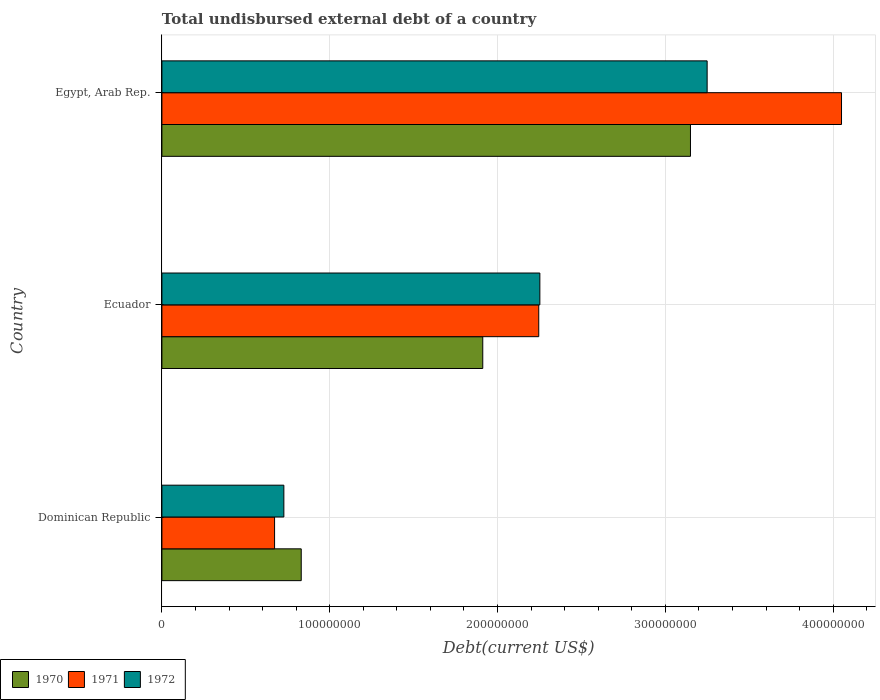How many groups of bars are there?
Make the answer very short. 3. How many bars are there on the 3rd tick from the top?
Keep it short and to the point. 3. What is the label of the 2nd group of bars from the top?
Ensure brevity in your answer.  Ecuador. What is the total undisbursed external debt in 1972 in Egypt, Arab Rep.?
Your answer should be compact. 3.25e+08. Across all countries, what is the maximum total undisbursed external debt in 1971?
Ensure brevity in your answer.  4.05e+08. Across all countries, what is the minimum total undisbursed external debt in 1971?
Make the answer very short. 6.71e+07. In which country was the total undisbursed external debt in 1971 maximum?
Give a very brief answer. Egypt, Arab Rep. In which country was the total undisbursed external debt in 1971 minimum?
Provide a short and direct response. Dominican Republic. What is the total total undisbursed external debt in 1971 in the graph?
Keep it short and to the point. 6.97e+08. What is the difference between the total undisbursed external debt in 1972 in Ecuador and that in Egypt, Arab Rep.?
Your answer should be very brief. -9.97e+07. What is the difference between the total undisbursed external debt in 1970 in Egypt, Arab Rep. and the total undisbursed external debt in 1971 in Dominican Republic?
Give a very brief answer. 2.48e+08. What is the average total undisbursed external debt in 1970 per country?
Provide a short and direct response. 1.96e+08. What is the difference between the total undisbursed external debt in 1971 and total undisbursed external debt in 1972 in Egypt, Arab Rep.?
Keep it short and to the point. 8.01e+07. In how many countries, is the total undisbursed external debt in 1971 greater than 320000000 US$?
Make the answer very short. 1. What is the ratio of the total undisbursed external debt in 1972 in Dominican Republic to that in Ecuador?
Your response must be concise. 0.32. Is the difference between the total undisbursed external debt in 1971 in Dominican Republic and Egypt, Arab Rep. greater than the difference between the total undisbursed external debt in 1972 in Dominican Republic and Egypt, Arab Rep.?
Ensure brevity in your answer.  No. What is the difference between the highest and the second highest total undisbursed external debt in 1971?
Keep it short and to the point. 1.80e+08. What is the difference between the highest and the lowest total undisbursed external debt in 1972?
Provide a succinct answer. 2.52e+08. Is the sum of the total undisbursed external debt in 1972 in Dominican Republic and Ecuador greater than the maximum total undisbursed external debt in 1971 across all countries?
Offer a very short reply. No. What does the 1st bar from the top in Egypt, Arab Rep. represents?
Provide a succinct answer. 1972. Is it the case that in every country, the sum of the total undisbursed external debt in 1970 and total undisbursed external debt in 1971 is greater than the total undisbursed external debt in 1972?
Your response must be concise. Yes. How many countries are there in the graph?
Offer a very short reply. 3. Does the graph contain grids?
Your answer should be very brief. Yes. Where does the legend appear in the graph?
Your response must be concise. Bottom left. How many legend labels are there?
Your answer should be compact. 3. How are the legend labels stacked?
Offer a terse response. Horizontal. What is the title of the graph?
Ensure brevity in your answer.  Total undisbursed external debt of a country. Does "2003" appear as one of the legend labels in the graph?
Give a very brief answer. No. What is the label or title of the X-axis?
Provide a short and direct response. Debt(current US$). What is the Debt(current US$) in 1970 in Dominican Republic?
Keep it short and to the point. 8.30e+07. What is the Debt(current US$) of 1971 in Dominican Republic?
Give a very brief answer. 6.71e+07. What is the Debt(current US$) of 1972 in Dominican Republic?
Your response must be concise. 7.27e+07. What is the Debt(current US$) in 1970 in Ecuador?
Keep it short and to the point. 1.91e+08. What is the Debt(current US$) of 1971 in Ecuador?
Offer a terse response. 2.25e+08. What is the Debt(current US$) of 1972 in Ecuador?
Offer a very short reply. 2.25e+08. What is the Debt(current US$) of 1970 in Egypt, Arab Rep.?
Offer a terse response. 3.15e+08. What is the Debt(current US$) of 1971 in Egypt, Arab Rep.?
Ensure brevity in your answer.  4.05e+08. What is the Debt(current US$) of 1972 in Egypt, Arab Rep.?
Your answer should be compact. 3.25e+08. Across all countries, what is the maximum Debt(current US$) in 1970?
Offer a terse response. 3.15e+08. Across all countries, what is the maximum Debt(current US$) of 1971?
Keep it short and to the point. 4.05e+08. Across all countries, what is the maximum Debt(current US$) of 1972?
Keep it short and to the point. 3.25e+08. Across all countries, what is the minimum Debt(current US$) of 1970?
Your answer should be compact. 8.30e+07. Across all countries, what is the minimum Debt(current US$) in 1971?
Offer a very short reply. 6.71e+07. Across all countries, what is the minimum Debt(current US$) in 1972?
Offer a terse response. 7.27e+07. What is the total Debt(current US$) of 1970 in the graph?
Keep it short and to the point. 5.89e+08. What is the total Debt(current US$) of 1971 in the graph?
Your response must be concise. 6.97e+08. What is the total Debt(current US$) in 1972 in the graph?
Your answer should be compact. 6.23e+08. What is the difference between the Debt(current US$) in 1970 in Dominican Republic and that in Ecuador?
Ensure brevity in your answer.  -1.08e+08. What is the difference between the Debt(current US$) of 1971 in Dominican Republic and that in Ecuador?
Make the answer very short. -1.57e+08. What is the difference between the Debt(current US$) in 1972 in Dominican Republic and that in Ecuador?
Your answer should be compact. -1.53e+08. What is the difference between the Debt(current US$) in 1970 in Dominican Republic and that in Egypt, Arab Rep.?
Offer a terse response. -2.32e+08. What is the difference between the Debt(current US$) of 1971 in Dominican Republic and that in Egypt, Arab Rep.?
Provide a succinct answer. -3.38e+08. What is the difference between the Debt(current US$) of 1972 in Dominican Republic and that in Egypt, Arab Rep.?
Give a very brief answer. -2.52e+08. What is the difference between the Debt(current US$) in 1970 in Ecuador and that in Egypt, Arab Rep.?
Your answer should be very brief. -1.24e+08. What is the difference between the Debt(current US$) of 1971 in Ecuador and that in Egypt, Arab Rep.?
Make the answer very short. -1.80e+08. What is the difference between the Debt(current US$) in 1972 in Ecuador and that in Egypt, Arab Rep.?
Provide a short and direct response. -9.97e+07. What is the difference between the Debt(current US$) in 1970 in Dominican Republic and the Debt(current US$) in 1971 in Ecuador?
Keep it short and to the point. -1.42e+08. What is the difference between the Debt(current US$) in 1970 in Dominican Republic and the Debt(current US$) in 1972 in Ecuador?
Give a very brief answer. -1.42e+08. What is the difference between the Debt(current US$) in 1971 in Dominican Republic and the Debt(current US$) in 1972 in Ecuador?
Offer a terse response. -1.58e+08. What is the difference between the Debt(current US$) of 1970 in Dominican Republic and the Debt(current US$) of 1971 in Egypt, Arab Rep.?
Make the answer very short. -3.22e+08. What is the difference between the Debt(current US$) of 1970 in Dominican Republic and the Debt(current US$) of 1972 in Egypt, Arab Rep.?
Your response must be concise. -2.42e+08. What is the difference between the Debt(current US$) of 1971 in Dominican Republic and the Debt(current US$) of 1972 in Egypt, Arab Rep.?
Your response must be concise. -2.58e+08. What is the difference between the Debt(current US$) in 1970 in Ecuador and the Debt(current US$) in 1971 in Egypt, Arab Rep.?
Ensure brevity in your answer.  -2.14e+08. What is the difference between the Debt(current US$) of 1970 in Ecuador and the Debt(current US$) of 1972 in Egypt, Arab Rep.?
Your answer should be compact. -1.34e+08. What is the difference between the Debt(current US$) of 1971 in Ecuador and the Debt(current US$) of 1972 in Egypt, Arab Rep.?
Provide a short and direct response. -1.00e+08. What is the average Debt(current US$) in 1970 per country?
Offer a terse response. 1.96e+08. What is the average Debt(current US$) of 1971 per country?
Your answer should be very brief. 2.32e+08. What is the average Debt(current US$) of 1972 per country?
Provide a short and direct response. 2.08e+08. What is the difference between the Debt(current US$) in 1970 and Debt(current US$) in 1971 in Dominican Republic?
Your response must be concise. 1.59e+07. What is the difference between the Debt(current US$) of 1970 and Debt(current US$) of 1972 in Dominican Republic?
Provide a succinct answer. 1.04e+07. What is the difference between the Debt(current US$) of 1971 and Debt(current US$) of 1972 in Dominican Republic?
Your answer should be compact. -5.54e+06. What is the difference between the Debt(current US$) in 1970 and Debt(current US$) in 1971 in Ecuador?
Make the answer very short. -3.34e+07. What is the difference between the Debt(current US$) in 1970 and Debt(current US$) in 1972 in Ecuador?
Your answer should be compact. -3.40e+07. What is the difference between the Debt(current US$) of 1971 and Debt(current US$) of 1972 in Ecuador?
Offer a very short reply. -6.61e+05. What is the difference between the Debt(current US$) of 1970 and Debt(current US$) of 1971 in Egypt, Arab Rep.?
Provide a short and direct response. -9.00e+07. What is the difference between the Debt(current US$) in 1970 and Debt(current US$) in 1972 in Egypt, Arab Rep.?
Give a very brief answer. -9.93e+06. What is the difference between the Debt(current US$) in 1971 and Debt(current US$) in 1972 in Egypt, Arab Rep.?
Provide a succinct answer. 8.01e+07. What is the ratio of the Debt(current US$) in 1970 in Dominican Republic to that in Ecuador?
Offer a terse response. 0.43. What is the ratio of the Debt(current US$) in 1971 in Dominican Republic to that in Ecuador?
Give a very brief answer. 0.3. What is the ratio of the Debt(current US$) of 1972 in Dominican Republic to that in Ecuador?
Give a very brief answer. 0.32. What is the ratio of the Debt(current US$) in 1970 in Dominican Republic to that in Egypt, Arab Rep.?
Keep it short and to the point. 0.26. What is the ratio of the Debt(current US$) in 1971 in Dominican Republic to that in Egypt, Arab Rep.?
Offer a very short reply. 0.17. What is the ratio of the Debt(current US$) of 1972 in Dominican Republic to that in Egypt, Arab Rep.?
Provide a short and direct response. 0.22. What is the ratio of the Debt(current US$) in 1970 in Ecuador to that in Egypt, Arab Rep.?
Offer a very short reply. 0.61. What is the ratio of the Debt(current US$) of 1971 in Ecuador to that in Egypt, Arab Rep.?
Offer a very short reply. 0.55. What is the ratio of the Debt(current US$) of 1972 in Ecuador to that in Egypt, Arab Rep.?
Keep it short and to the point. 0.69. What is the difference between the highest and the second highest Debt(current US$) in 1970?
Offer a terse response. 1.24e+08. What is the difference between the highest and the second highest Debt(current US$) in 1971?
Keep it short and to the point. 1.80e+08. What is the difference between the highest and the second highest Debt(current US$) in 1972?
Make the answer very short. 9.97e+07. What is the difference between the highest and the lowest Debt(current US$) in 1970?
Make the answer very short. 2.32e+08. What is the difference between the highest and the lowest Debt(current US$) of 1971?
Your answer should be compact. 3.38e+08. What is the difference between the highest and the lowest Debt(current US$) in 1972?
Make the answer very short. 2.52e+08. 